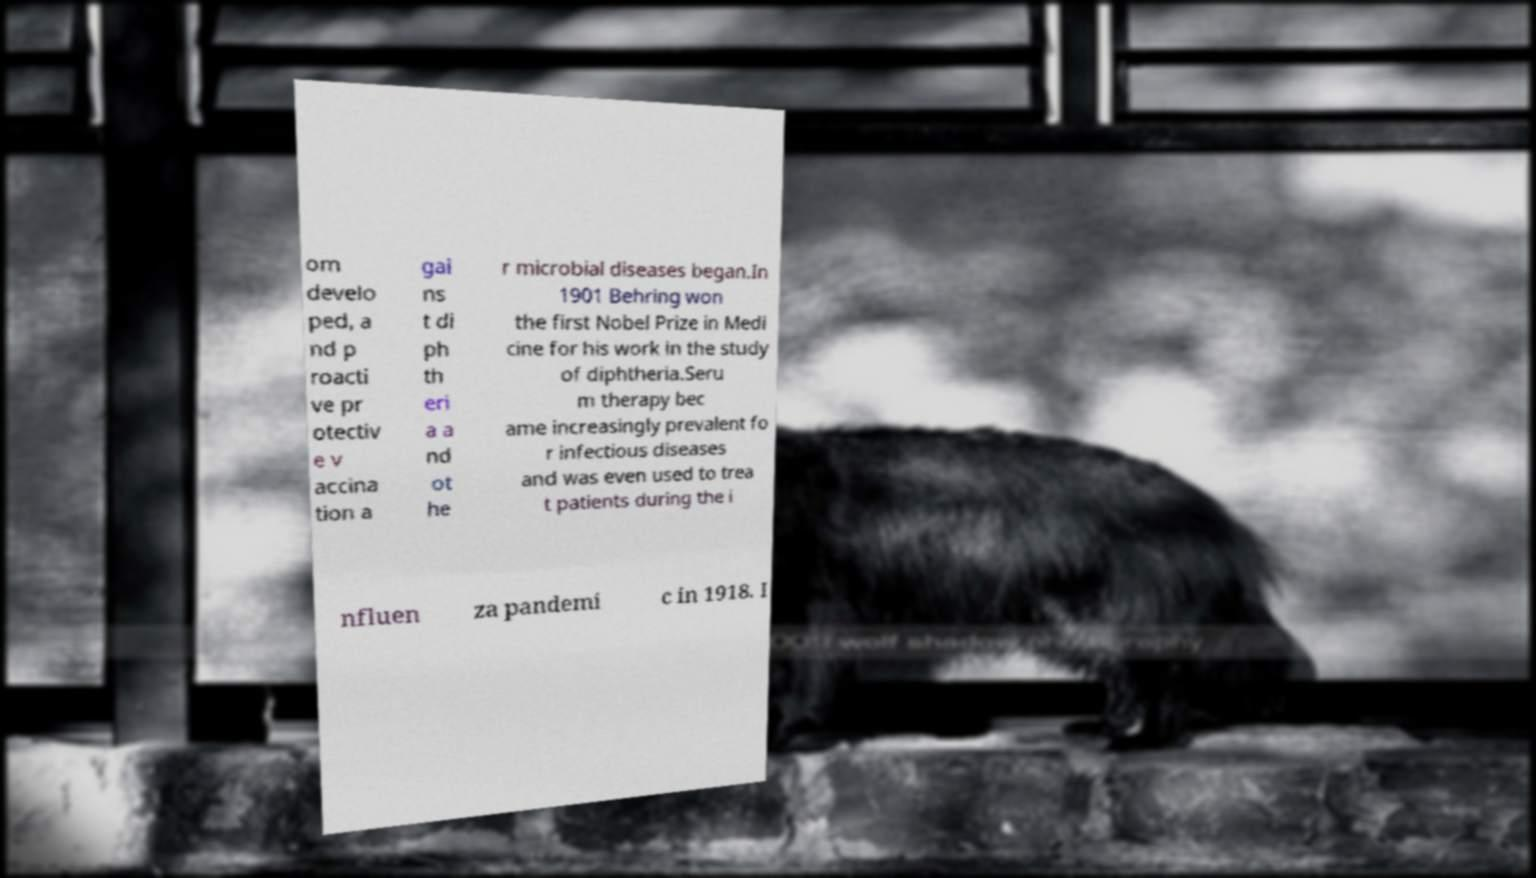Could you assist in decoding the text presented in this image and type it out clearly? om develo ped, a nd p roacti ve pr otectiv e v accina tion a gai ns t di ph th eri a a nd ot he r microbial diseases began.In 1901 Behring won the first Nobel Prize in Medi cine for his work in the study of diphtheria.Seru m therapy bec ame increasingly prevalent fo r infectious diseases and was even used to trea t patients during the i nfluen za pandemi c in 1918. I 